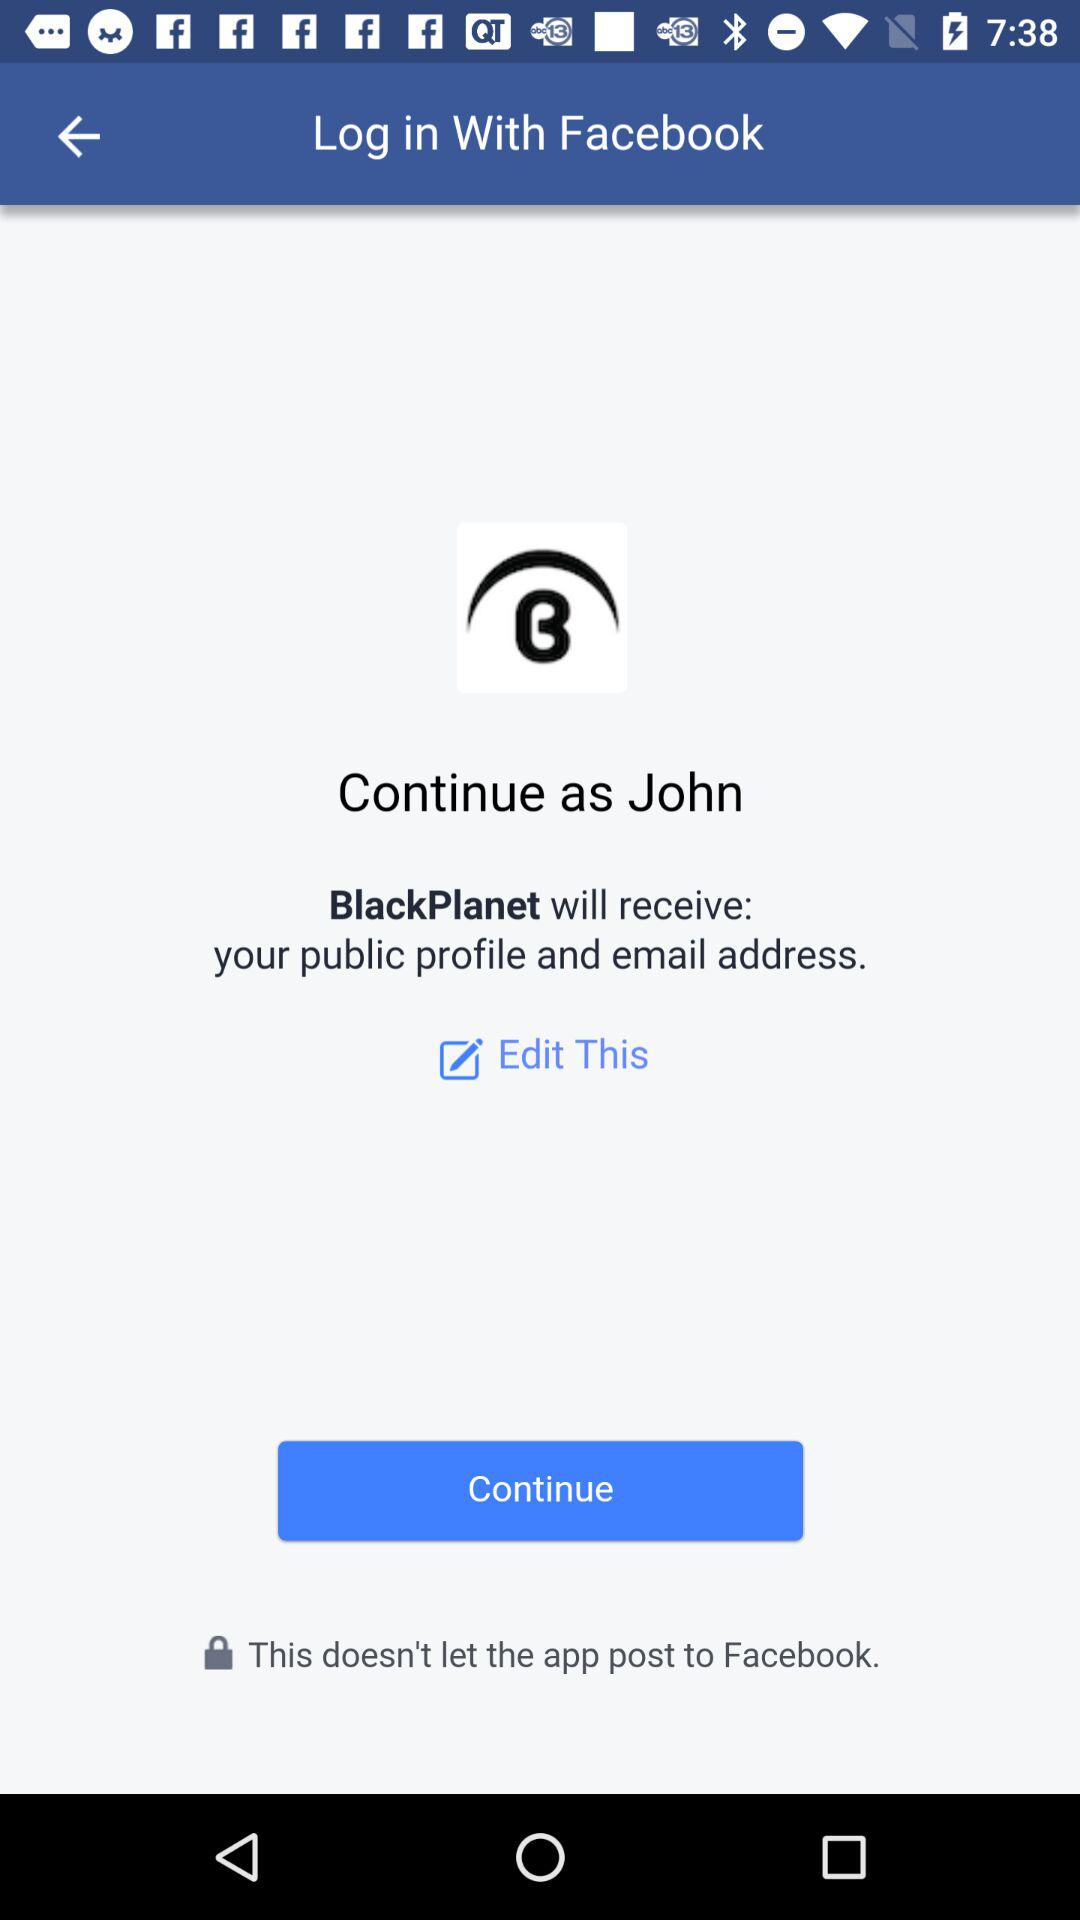What application can be used to log in to a profile? The application that can be used to log in is "Facebook". 